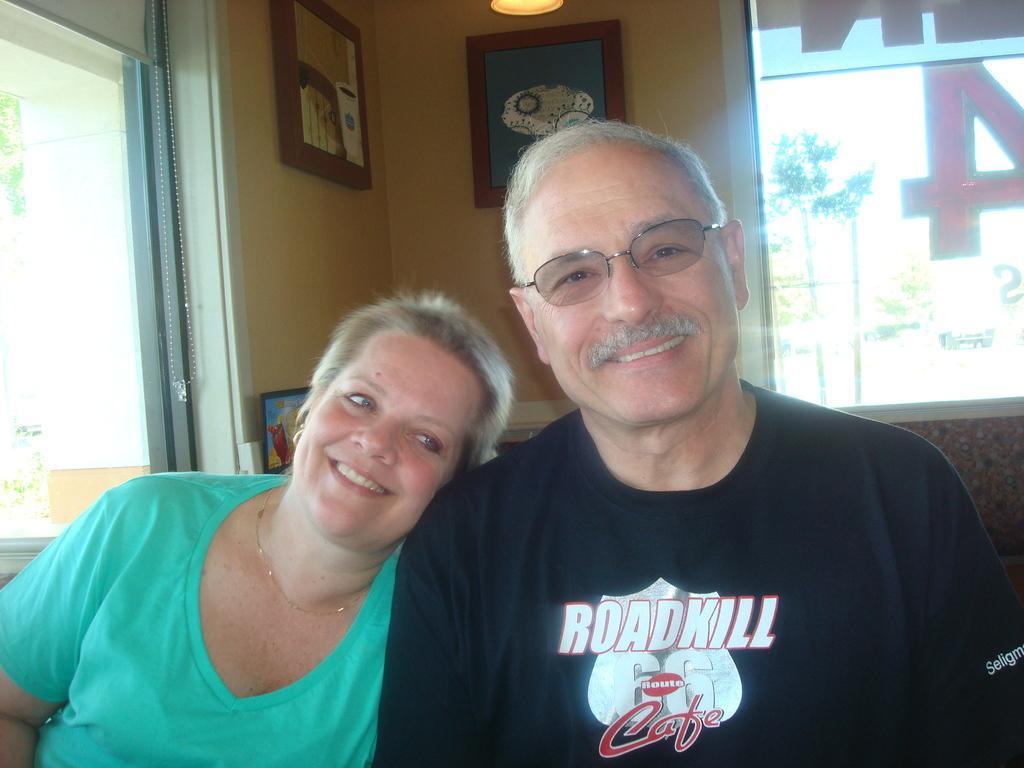Could you give a brief overview of what you see in this image? In the picture we can see a man and a woman sitting on the chair and the woman is leaning on the man and man is wearing a black T-shirt and woman is wearing a blue dress and in the background we can see a wall with glass windows and into the wall we can see some photo frames. 